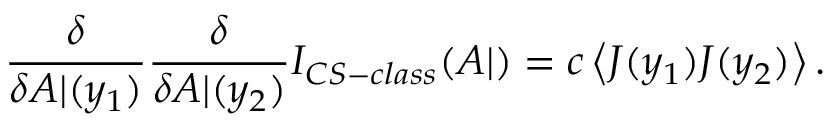Convert formula to latex. <formula><loc_0><loc_0><loc_500><loc_500>\frac { \delta } { \delta A | ( y _ { 1 } ) } \frac { \delta } { \delta A | ( y _ { 2 } ) } I _ { C S - c l a s s } ( A | ) = c \left < J ( y _ { 1 } ) J ( y _ { 2 } ) \right > .</formula> 